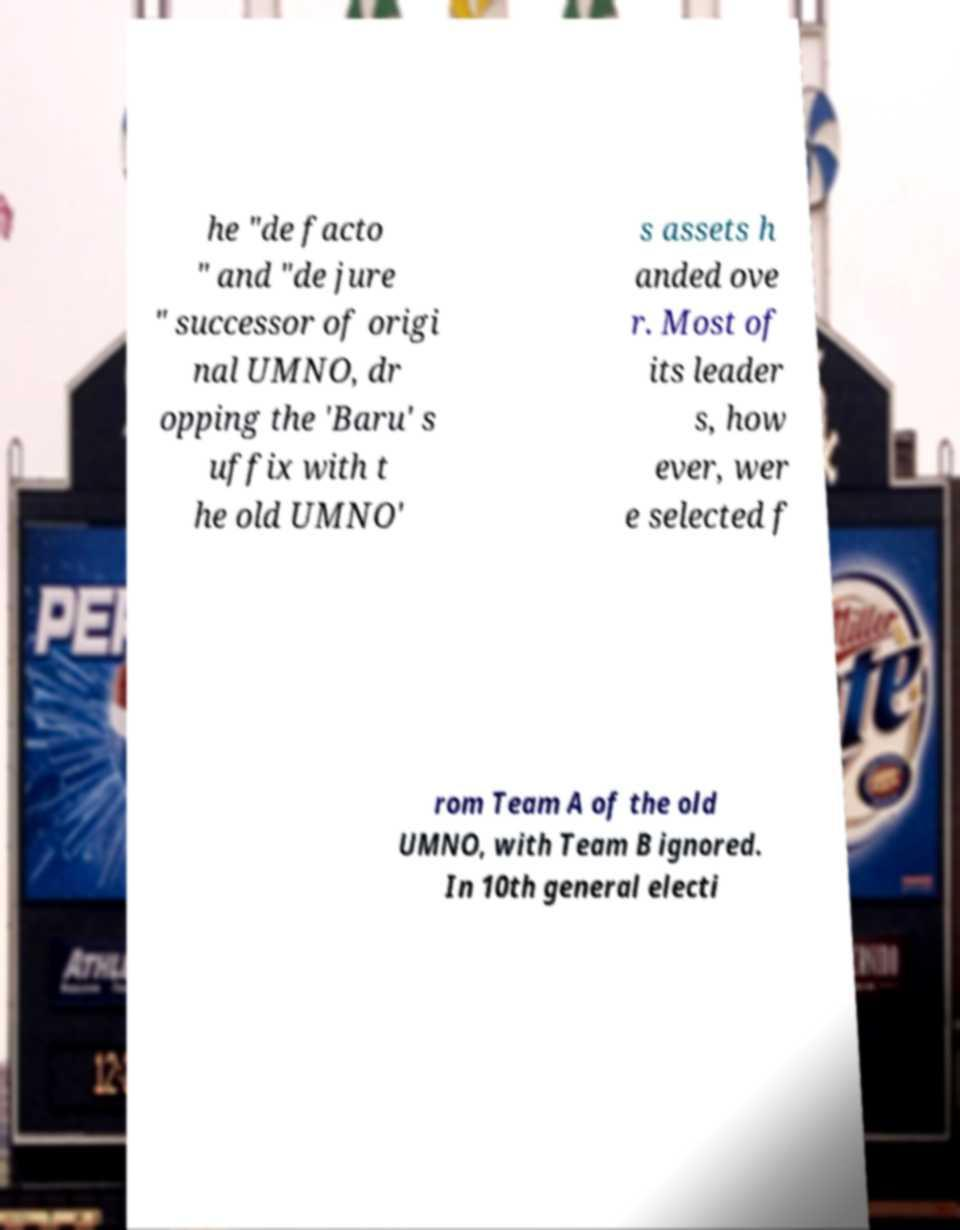Could you extract and type out the text from this image? he "de facto " and "de jure " successor of origi nal UMNO, dr opping the 'Baru' s uffix with t he old UMNO' s assets h anded ove r. Most of its leader s, how ever, wer e selected f rom Team A of the old UMNO, with Team B ignored. In 10th general electi 